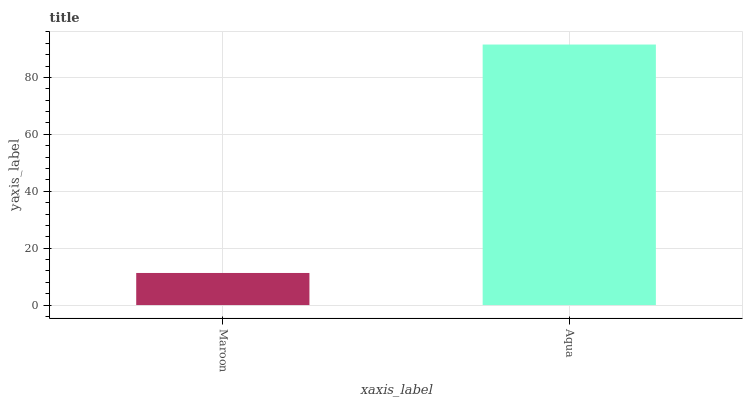Is Maroon the minimum?
Answer yes or no. Yes. Is Aqua the maximum?
Answer yes or no. Yes. Is Aqua the minimum?
Answer yes or no. No. Is Aqua greater than Maroon?
Answer yes or no. Yes. Is Maroon less than Aqua?
Answer yes or no. Yes. Is Maroon greater than Aqua?
Answer yes or no. No. Is Aqua less than Maroon?
Answer yes or no. No. Is Aqua the high median?
Answer yes or no. Yes. Is Maroon the low median?
Answer yes or no. Yes. Is Maroon the high median?
Answer yes or no. No. Is Aqua the low median?
Answer yes or no. No. 